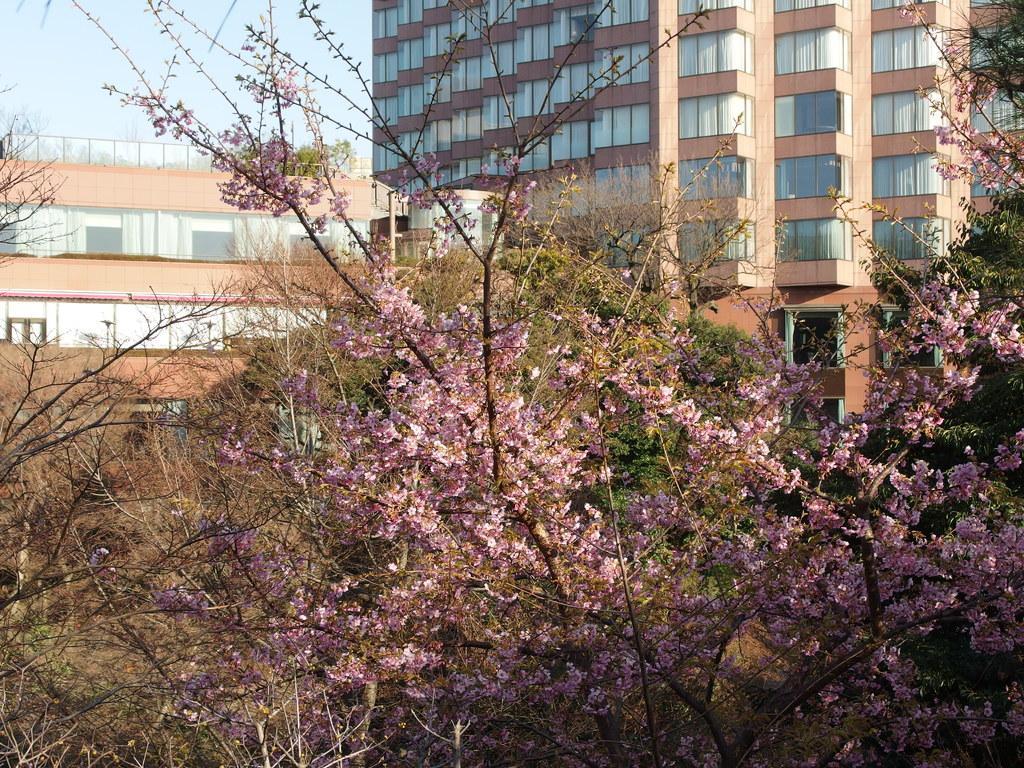Please provide a concise description of this image. In this image there are trees, a tree with pink color flowers,and in the background there are buildings,sky. 